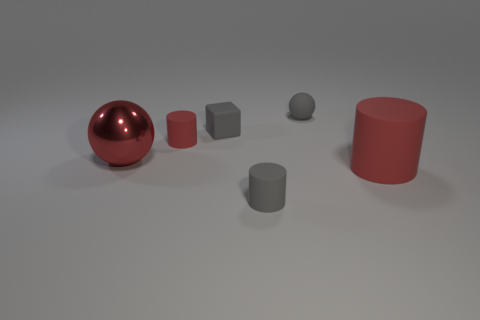Is the shape of the big rubber thing the same as the large red metal object?
Ensure brevity in your answer.  No. What material is the small gray ball behind the red cylinder on the left side of the gray sphere?
Your response must be concise. Rubber. What material is the small object that is the same color as the big rubber thing?
Your answer should be compact. Rubber. Do the gray cylinder and the gray cube have the same size?
Your response must be concise. Yes. There is a tiny gray rubber object in front of the big rubber cylinder; are there any gray rubber objects that are left of it?
Your answer should be very brief. Yes. What is the size of the sphere that is the same color as the big cylinder?
Offer a terse response. Large. What is the shape of the red rubber thing behind the large red metal thing?
Your answer should be compact. Cylinder. What number of red cylinders are behind the red matte cylinder that is in front of the small matte cylinder to the left of the gray matte cylinder?
Offer a very short reply. 1. There is a red metallic ball; does it have the same size as the red cylinder that is left of the tiny matte ball?
Keep it short and to the point. No. There is a red matte cylinder on the left side of the red thing that is right of the small sphere; how big is it?
Provide a succinct answer. Small. 